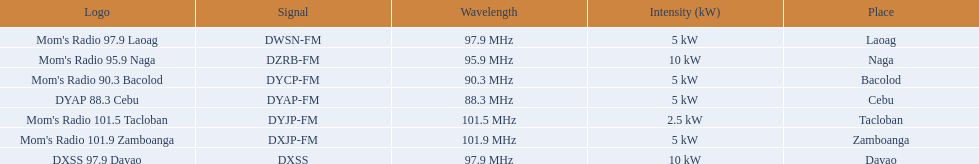Which of these stations broadcasts with the least power? Mom's Radio 101.5 Tacloban. 